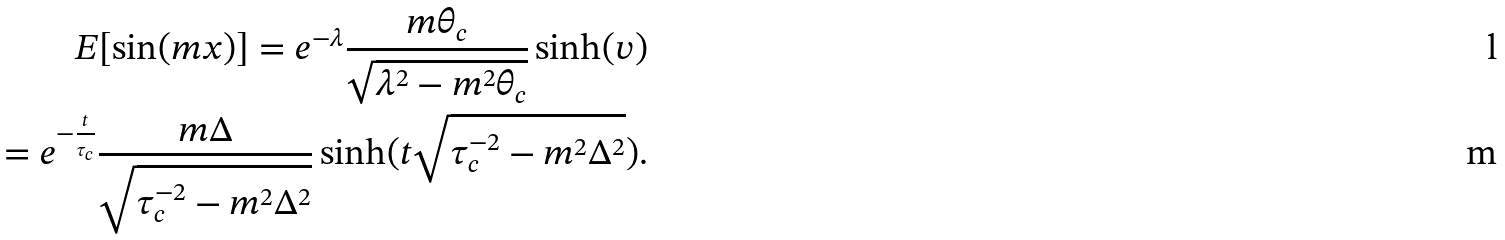<formula> <loc_0><loc_0><loc_500><loc_500>E [ \sin ( m x ) ] = e ^ { - \lambda } \frac { m \theta _ { c } } { \sqrt { \lambda ^ { 2 } - m ^ { 2 } \theta _ { c } } } \sinh ( v ) \\ = e ^ { - \frac { t } { \tau _ { c } } } \frac { m \Delta } { \sqrt { \tau _ { c } ^ { - 2 } - m ^ { 2 } \Delta ^ { 2 } } } \sinh ( t \sqrt { \tau _ { c } ^ { - 2 } - m ^ { 2 } \Delta ^ { 2 } } ) .</formula> 